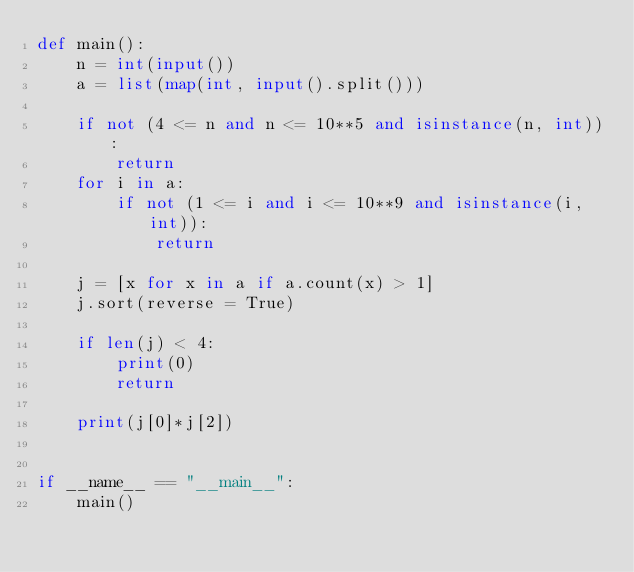<code> <loc_0><loc_0><loc_500><loc_500><_Python_>def main():
    n = int(input())
    a = list(map(int, input().split()))

    if not (4 <= n and n <= 10**5 and isinstance(n, int)):
        return
    for i in a:
        if not (1 <= i and i <= 10**9 and isinstance(i, int)):
            return

    j = [x for x in a if a.count(x) > 1]
    j.sort(reverse = True)

    if len(j) < 4:
        print(0)
        return

    print(j[0]*j[2])


if __name__ == "__main__":
    main()</code> 